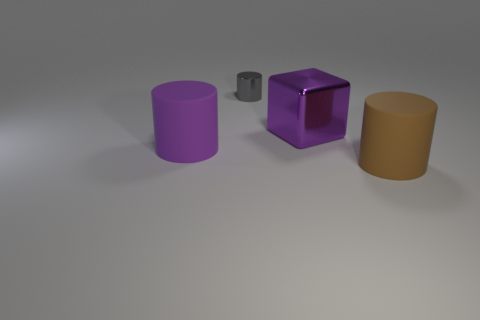Add 3 large brown cylinders. How many objects exist? 7 Subtract all purple matte cylinders. How many cylinders are left? 2 Subtract all blocks. How many objects are left? 3 Subtract 2 cylinders. How many cylinders are left? 1 Subtract all purple cylinders. How many cylinders are left? 2 Subtract all blue blocks. Subtract all yellow spheres. How many blocks are left? 1 Subtract all purple cubes. How many purple cylinders are left? 1 Subtract all tiny shiny blocks. Subtract all purple metallic things. How many objects are left? 3 Add 4 tiny objects. How many tiny objects are left? 5 Add 2 gray metallic things. How many gray metallic things exist? 3 